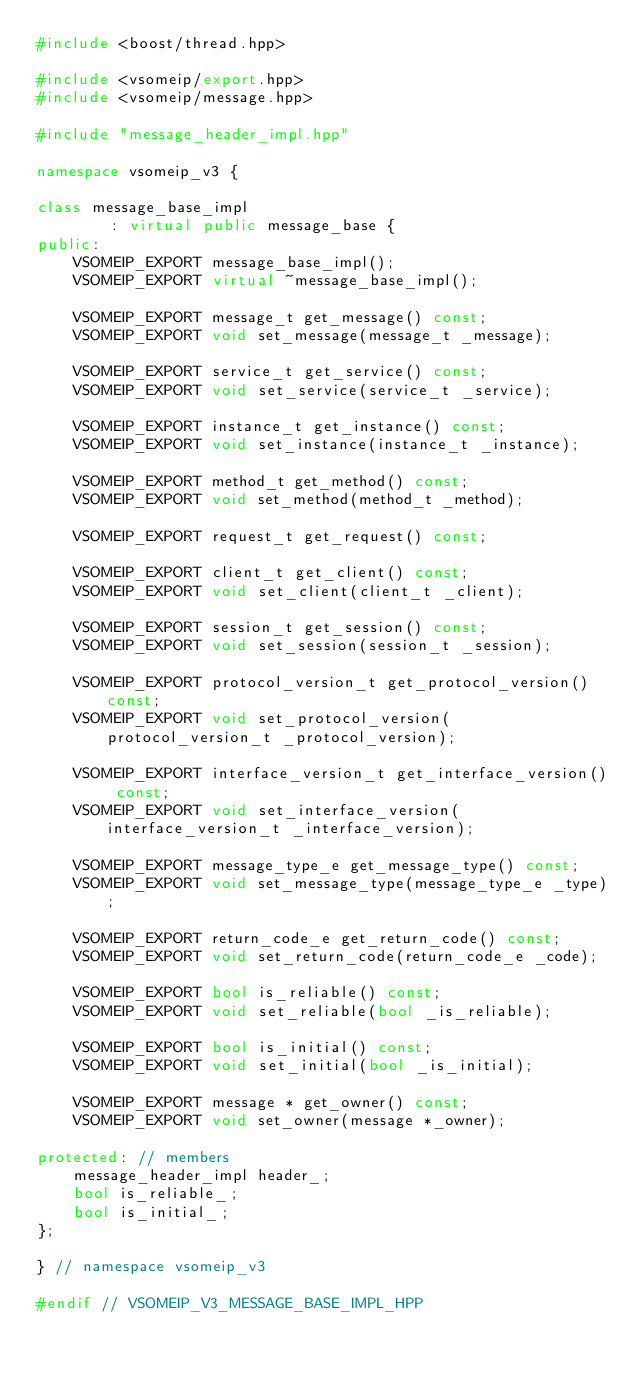<code> <loc_0><loc_0><loc_500><loc_500><_C++_>#include <boost/thread.hpp>

#include <vsomeip/export.hpp>
#include <vsomeip/message.hpp>

#include "message_header_impl.hpp"

namespace vsomeip_v3 {

class message_base_impl
        : virtual public message_base {
public:
    VSOMEIP_EXPORT message_base_impl();
    VSOMEIP_EXPORT virtual ~message_base_impl();

    VSOMEIP_EXPORT message_t get_message() const;
    VSOMEIP_EXPORT void set_message(message_t _message);

    VSOMEIP_EXPORT service_t get_service() const;
    VSOMEIP_EXPORT void set_service(service_t _service);

    VSOMEIP_EXPORT instance_t get_instance() const;
    VSOMEIP_EXPORT void set_instance(instance_t _instance);

    VSOMEIP_EXPORT method_t get_method() const;
    VSOMEIP_EXPORT void set_method(method_t _method);

    VSOMEIP_EXPORT request_t get_request() const;

    VSOMEIP_EXPORT client_t get_client() const;
    VSOMEIP_EXPORT void set_client(client_t _client);

    VSOMEIP_EXPORT session_t get_session() const;
    VSOMEIP_EXPORT void set_session(session_t _session);

    VSOMEIP_EXPORT protocol_version_t get_protocol_version() const;
    VSOMEIP_EXPORT void set_protocol_version(protocol_version_t _protocol_version);

    VSOMEIP_EXPORT interface_version_t get_interface_version() const;
    VSOMEIP_EXPORT void set_interface_version(interface_version_t _interface_version);

    VSOMEIP_EXPORT message_type_e get_message_type() const;
    VSOMEIP_EXPORT void set_message_type(message_type_e _type);

    VSOMEIP_EXPORT return_code_e get_return_code() const;
    VSOMEIP_EXPORT void set_return_code(return_code_e _code);

    VSOMEIP_EXPORT bool is_reliable() const;
    VSOMEIP_EXPORT void set_reliable(bool _is_reliable);

    VSOMEIP_EXPORT bool is_initial() const;
    VSOMEIP_EXPORT void set_initial(bool _is_initial);

    VSOMEIP_EXPORT message * get_owner() const;
    VSOMEIP_EXPORT void set_owner(message *_owner);

protected: // members
    message_header_impl header_;
    bool is_reliable_;
    bool is_initial_;
};

} // namespace vsomeip_v3

#endif // VSOMEIP_V3_MESSAGE_BASE_IMPL_HPP
</code> 